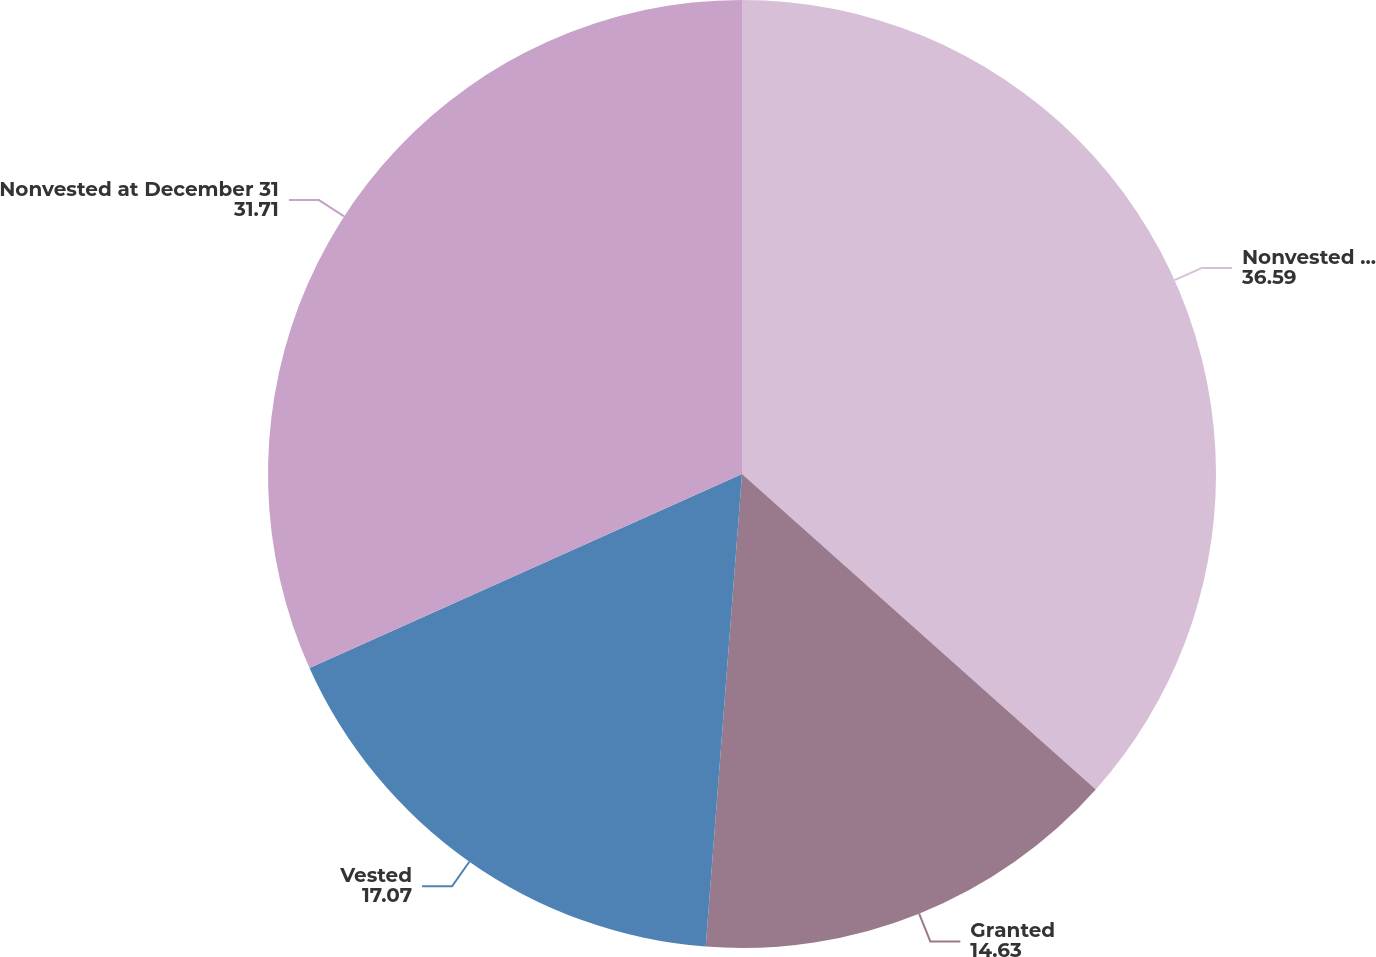Convert chart. <chart><loc_0><loc_0><loc_500><loc_500><pie_chart><fcel>Nonvested at January 1<fcel>Granted<fcel>Vested<fcel>Nonvested at December 31<nl><fcel>36.59%<fcel>14.63%<fcel>17.07%<fcel>31.71%<nl></chart> 